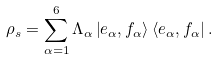Convert formula to latex. <formula><loc_0><loc_0><loc_500><loc_500>\rho _ { s } = \sum _ { \alpha = 1 } ^ { 6 } \Lambda _ { \alpha } \left | e _ { \alpha } , f _ { \alpha } \right > \left < e _ { \alpha } , f _ { \alpha } \right | .</formula> 